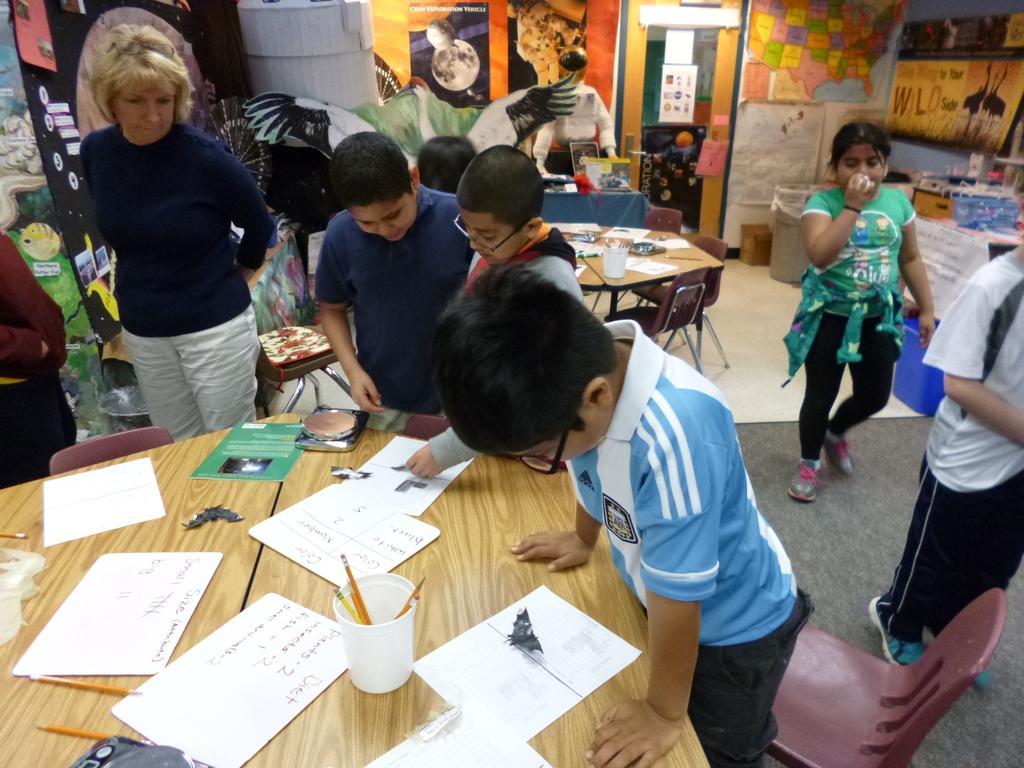In one or two sentences, can you explain what this image depicts? As we can see in the image there are posters, few people here and there and a table. On table there are papers, pencils and a glass. 